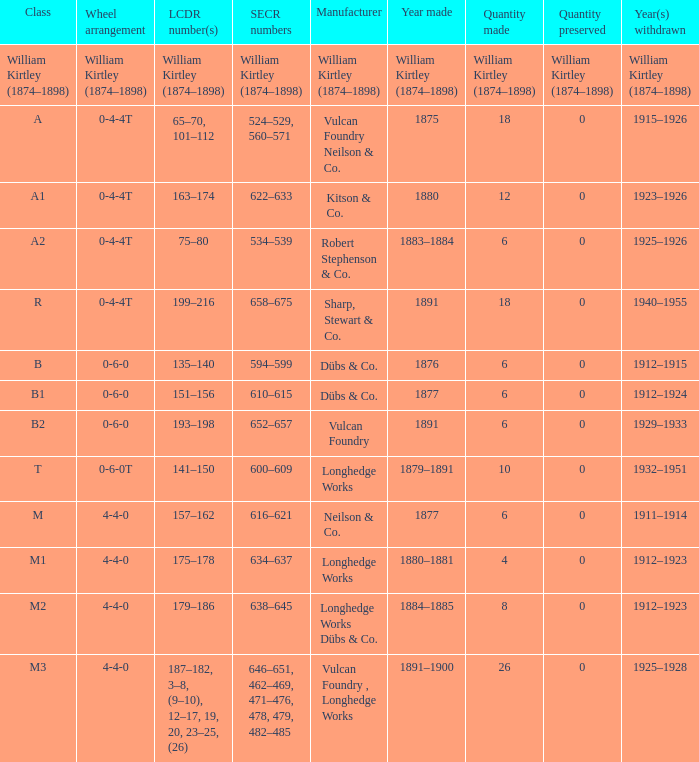Which category was created in 1880? A1. 